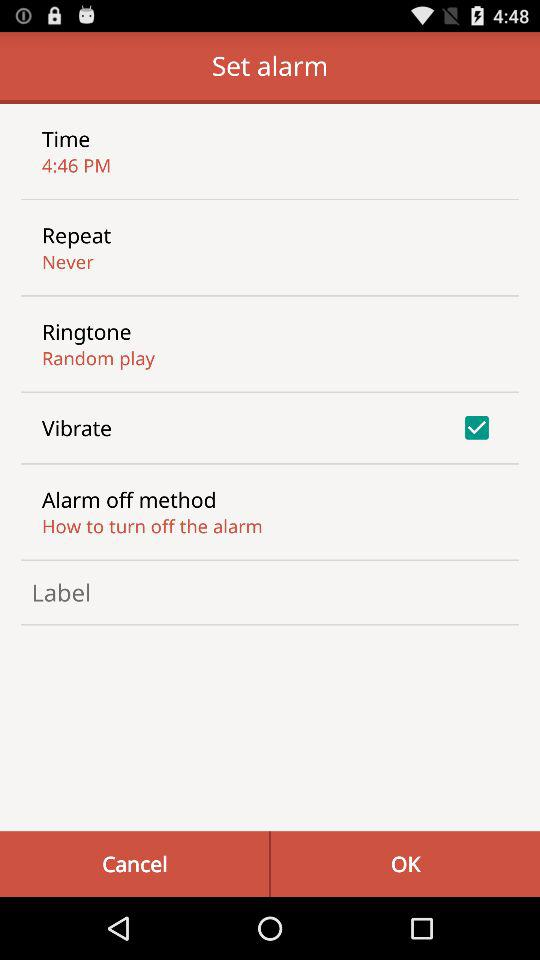What is the status of the "Vibrate"? The status of the "Vibrate" is "on". 